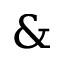Convert formula to latex. <formula><loc_0><loc_0><loc_500><loc_500>\&</formula> 